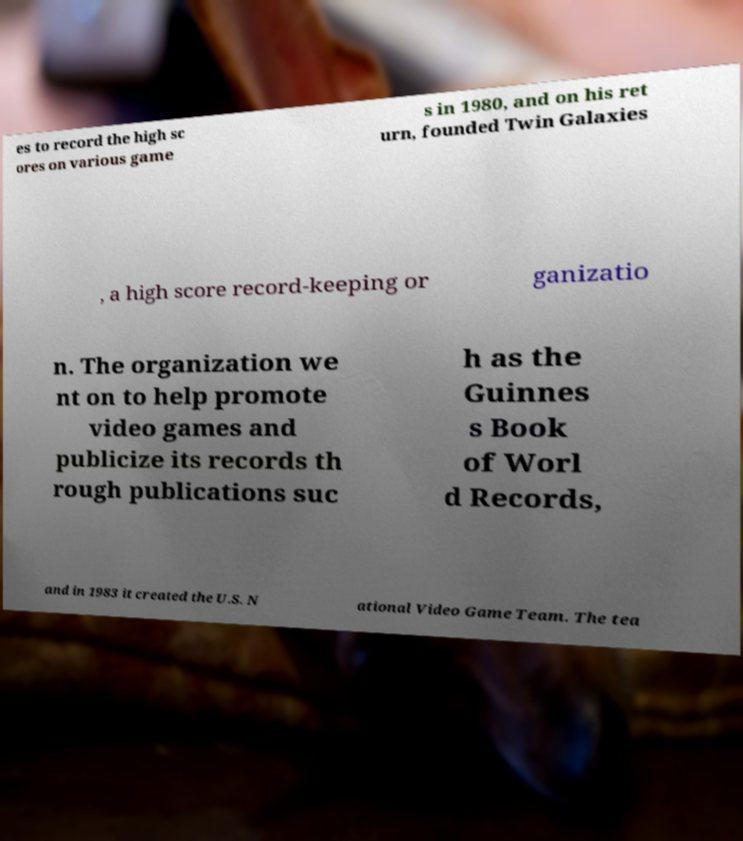Can you accurately transcribe the text from the provided image for me? es to record the high sc ores on various game s in 1980, and on his ret urn, founded Twin Galaxies , a high score record-keeping or ganizatio n. The organization we nt on to help promote video games and publicize its records th rough publications suc h as the Guinnes s Book of Worl d Records, and in 1983 it created the U.S. N ational Video Game Team. The tea 